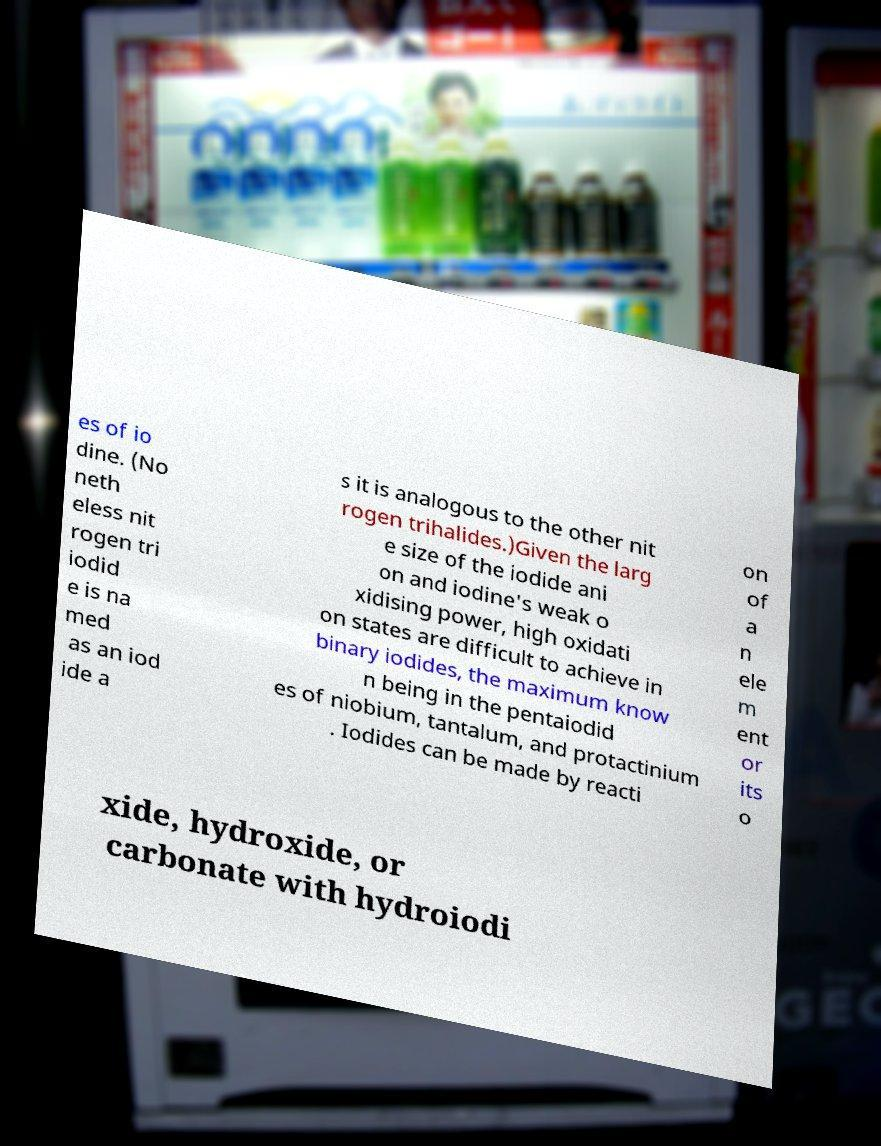Could you assist in decoding the text presented in this image and type it out clearly? es of io dine. (No neth eless nit rogen tri iodid e is na med as an iod ide a s it is analogous to the other nit rogen trihalides.)Given the larg e size of the iodide ani on and iodine's weak o xidising power, high oxidati on states are difficult to achieve in binary iodides, the maximum know n being in the pentaiodid es of niobium, tantalum, and protactinium . Iodides can be made by reacti on of a n ele m ent or its o xide, hydroxide, or carbonate with hydroiodi 